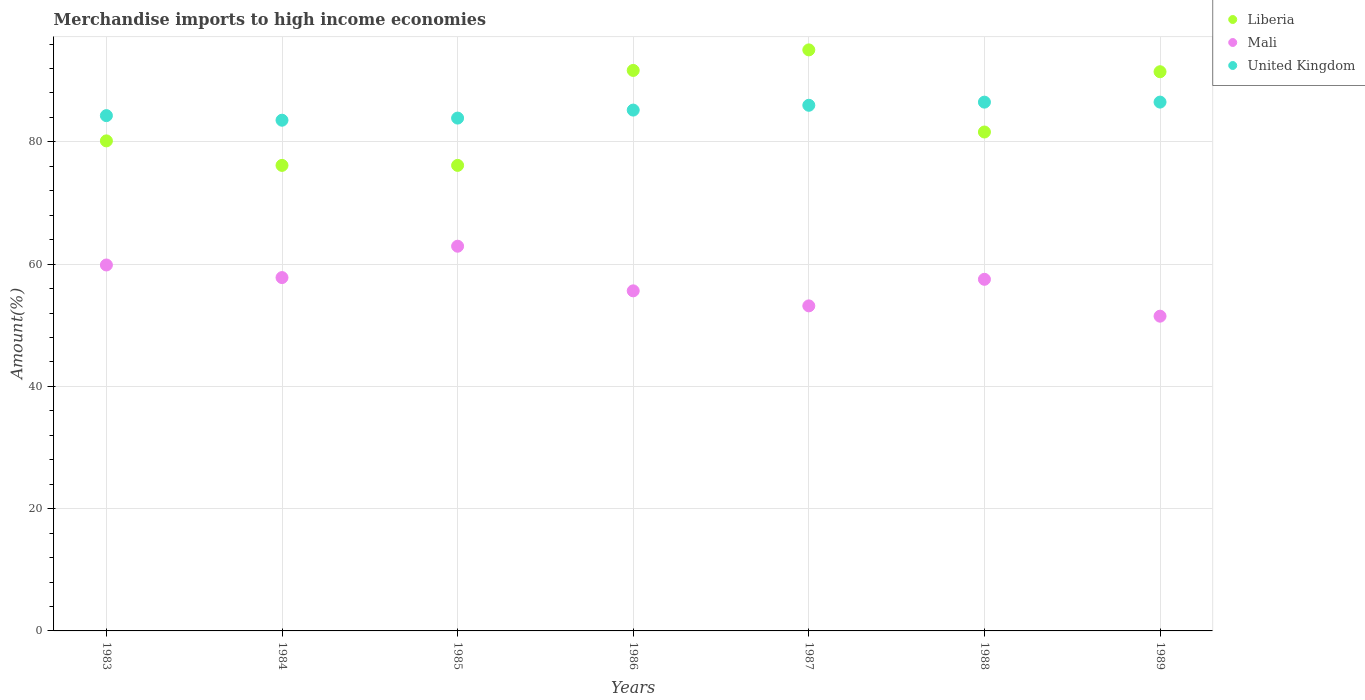How many different coloured dotlines are there?
Your answer should be compact. 3. Is the number of dotlines equal to the number of legend labels?
Give a very brief answer. Yes. What is the percentage of amount earned from merchandise imports in Mali in 1987?
Your response must be concise. 53.17. Across all years, what is the maximum percentage of amount earned from merchandise imports in Liberia?
Provide a succinct answer. 95.04. Across all years, what is the minimum percentage of amount earned from merchandise imports in United Kingdom?
Offer a terse response. 83.54. What is the total percentage of amount earned from merchandise imports in United Kingdom in the graph?
Offer a terse response. 595.89. What is the difference between the percentage of amount earned from merchandise imports in United Kingdom in 1987 and that in 1989?
Your answer should be compact. -0.52. What is the difference between the percentage of amount earned from merchandise imports in Liberia in 1983 and the percentage of amount earned from merchandise imports in United Kingdom in 1989?
Your answer should be very brief. -6.34. What is the average percentage of amount earned from merchandise imports in Mali per year?
Offer a very short reply. 56.91. In the year 1988, what is the difference between the percentage of amount earned from merchandise imports in Mali and percentage of amount earned from merchandise imports in United Kingdom?
Give a very brief answer. -28.98. In how many years, is the percentage of amount earned from merchandise imports in Liberia greater than 28 %?
Provide a short and direct response. 7. What is the ratio of the percentage of amount earned from merchandise imports in Liberia in 1984 to that in 1988?
Your answer should be compact. 0.93. Is the difference between the percentage of amount earned from merchandise imports in Mali in 1983 and 1987 greater than the difference between the percentage of amount earned from merchandise imports in United Kingdom in 1983 and 1987?
Ensure brevity in your answer.  Yes. What is the difference between the highest and the second highest percentage of amount earned from merchandise imports in Mali?
Your response must be concise. 3.07. What is the difference between the highest and the lowest percentage of amount earned from merchandise imports in Mali?
Offer a very short reply. 11.44. Is it the case that in every year, the sum of the percentage of amount earned from merchandise imports in Mali and percentage of amount earned from merchandise imports in United Kingdom  is greater than the percentage of amount earned from merchandise imports in Liberia?
Provide a short and direct response. Yes. Does the percentage of amount earned from merchandise imports in Mali monotonically increase over the years?
Offer a very short reply. No. Is the percentage of amount earned from merchandise imports in United Kingdom strictly greater than the percentage of amount earned from merchandise imports in Mali over the years?
Your answer should be very brief. Yes. How many years are there in the graph?
Ensure brevity in your answer.  7. What is the difference between two consecutive major ticks on the Y-axis?
Your answer should be very brief. 20. Does the graph contain any zero values?
Provide a short and direct response. No. Where does the legend appear in the graph?
Give a very brief answer. Top right. How many legend labels are there?
Provide a succinct answer. 3. How are the legend labels stacked?
Your answer should be very brief. Vertical. What is the title of the graph?
Your answer should be very brief. Merchandise imports to high income economies. Does "Uzbekistan" appear as one of the legend labels in the graph?
Give a very brief answer. No. What is the label or title of the Y-axis?
Your answer should be very brief. Amount(%). What is the Amount(%) in Liberia in 1983?
Offer a very short reply. 80.16. What is the Amount(%) in Mali in 1983?
Provide a succinct answer. 59.86. What is the Amount(%) of United Kingdom in 1983?
Give a very brief answer. 84.29. What is the Amount(%) in Liberia in 1984?
Your response must be concise. 76.15. What is the Amount(%) in Mali in 1984?
Ensure brevity in your answer.  57.8. What is the Amount(%) in United Kingdom in 1984?
Your response must be concise. 83.54. What is the Amount(%) of Liberia in 1985?
Your answer should be compact. 76.15. What is the Amount(%) of Mali in 1985?
Offer a very short reply. 62.93. What is the Amount(%) in United Kingdom in 1985?
Offer a terse response. 83.89. What is the Amount(%) of Liberia in 1986?
Your answer should be very brief. 91.68. What is the Amount(%) in Mali in 1986?
Provide a short and direct response. 55.63. What is the Amount(%) in United Kingdom in 1986?
Make the answer very short. 85.19. What is the Amount(%) of Liberia in 1987?
Your response must be concise. 95.04. What is the Amount(%) of Mali in 1987?
Give a very brief answer. 53.17. What is the Amount(%) in United Kingdom in 1987?
Provide a succinct answer. 85.98. What is the Amount(%) of Liberia in 1988?
Offer a very short reply. 81.61. What is the Amount(%) of Mali in 1988?
Provide a succinct answer. 57.51. What is the Amount(%) in United Kingdom in 1988?
Offer a very short reply. 86.49. What is the Amount(%) of Liberia in 1989?
Your answer should be compact. 91.47. What is the Amount(%) of Mali in 1989?
Your response must be concise. 51.48. What is the Amount(%) of United Kingdom in 1989?
Offer a terse response. 86.5. Across all years, what is the maximum Amount(%) in Liberia?
Your answer should be very brief. 95.04. Across all years, what is the maximum Amount(%) in Mali?
Offer a very short reply. 62.93. Across all years, what is the maximum Amount(%) in United Kingdom?
Offer a terse response. 86.5. Across all years, what is the minimum Amount(%) of Liberia?
Make the answer very short. 76.15. Across all years, what is the minimum Amount(%) of Mali?
Provide a short and direct response. 51.48. Across all years, what is the minimum Amount(%) in United Kingdom?
Make the answer very short. 83.54. What is the total Amount(%) of Liberia in the graph?
Your response must be concise. 592.26. What is the total Amount(%) of Mali in the graph?
Offer a very short reply. 398.38. What is the total Amount(%) in United Kingdom in the graph?
Keep it short and to the point. 595.89. What is the difference between the Amount(%) of Liberia in 1983 and that in 1984?
Make the answer very short. 4.01. What is the difference between the Amount(%) in Mali in 1983 and that in 1984?
Your answer should be compact. 2.06. What is the difference between the Amount(%) in United Kingdom in 1983 and that in 1984?
Make the answer very short. 0.75. What is the difference between the Amount(%) in Liberia in 1983 and that in 1985?
Keep it short and to the point. 4.01. What is the difference between the Amount(%) in Mali in 1983 and that in 1985?
Give a very brief answer. -3.07. What is the difference between the Amount(%) in United Kingdom in 1983 and that in 1985?
Give a very brief answer. 0.4. What is the difference between the Amount(%) of Liberia in 1983 and that in 1986?
Offer a very short reply. -11.52. What is the difference between the Amount(%) of Mali in 1983 and that in 1986?
Ensure brevity in your answer.  4.23. What is the difference between the Amount(%) of United Kingdom in 1983 and that in 1986?
Keep it short and to the point. -0.91. What is the difference between the Amount(%) in Liberia in 1983 and that in 1987?
Ensure brevity in your answer.  -14.88. What is the difference between the Amount(%) of Mali in 1983 and that in 1987?
Make the answer very short. 6.69. What is the difference between the Amount(%) in United Kingdom in 1983 and that in 1987?
Provide a succinct answer. -1.69. What is the difference between the Amount(%) of Liberia in 1983 and that in 1988?
Offer a very short reply. -1.45. What is the difference between the Amount(%) in Mali in 1983 and that in 1988?
Give a very brief answer. 2.34. What is the difference between the Amount(%) of United Kingdom in 1983 and that in 1988?
Your answer should be very brief. -2.21. What is the difference between the Amount(%) in Liberia in 1983 and that in 1989?
Your answer should be very brief. -11.31. What is the difference between the Amount(%) in Mali in 1983 and that in 1989?
Provide a short and direct response. 8.37. What is the difference between the Amount(%) of United Kingdom in 1983 and that in 1989?
Provide a succinct answer. -2.21. What is the difference between the Amount(%) in Mali in 1984 and that in 1985?
Offer a very short reply. -5.13. What is the difference between the Amount(%) in United Kingdom in 1984 and that in 1985?
Provide a succinct answer. -0.35. What is the difference between the Amount(%) in Liberia in 1984 and that in 1986?
Offer a very short reply. -15.53. What is the difference between the Amount(%) in Mali in 1984 and that in 1986?
Ensure brevity in your answer.  2.17. What is the difference between the Amount(%) in United Kingdom in 1984 and that in 1986?
Your response must be concise. -1.66. What is the difference between the Amount(%) in Liberia in 1984 and that in 1987?
Keep it short and to the point. -18.89. What is the difference between the Amount(%) of Mali in 1984 and that in 1987?
Offer a terse response. 4.63. What is the difference between the Amount(%) of United Kingdom in 1984 and that in 1987?
Offer a terse response. -2.44. What is the difference between the Amount(%) of Liberia in 1984 and that in 1988?
Make the answer very short. -5.46. What is the difference between the Amount(%) in Mali in 1984 and that in 1988?
Your answer should be compact. 0.28. What is the difference between the Amount(%) of United Kingdom in 1984 and that in 1988?
Make the answer very short. -2.96. What is the difference between the Amount(%) in Liberia in 1984 and that in 1989?
Provide a succinct answer. -15.32. What is the difference between the Amount(%) in Mali in 1984 and that in 1989?
Give a very brief answer. 6.31. What is the difference between the Amount(%) of United Kingdom in 1984 and that in 1989?
Offer a terse response. -2.96. What is the difference between the Amount(%) in Liberia in 1985 and that in 1986?
Your answer should be very brief. -15.53. What is the difference between the Amount(%) in Mali in 1985 and that in 1986?
Give a very brief answer. 7.3. What is the difference between the Amount(%) in United Kingdom in 1985 and that in 1986?
Ensure brevity in your answer.  -1.31. What is the difference between the Amount(%) in Liberia in 1985 and that in 1987?
Make the answer very short. -18.89. What is the difference between the Amount(%) of Mali in 1985 and that in 1987?
Offer a terse response. 9.76. What is the difference between the Amount(%) in United Kingdom in 1985 and that in 1987?
Keep it short and to the point. -2.1. What is the difference between the Amount(%) in Liberia in 1985 and that in 1988?
Your response must be concise. -5.46. What is the difference between the Amount(%) in Mali in 1985 and that in 1988?
Keep it short and to the point. 5.41. What is the difference between the Amount(%) in United Kingdom in 1985 and that in 1988?
Make the answer very short. -2.61. What is the difference between the Amount(%) of Liberia in 1985 and that in 1989?
Provide a succinct answer. -15.32. What is the difference between the Amount(%) in Mali in 1985 and that in 1989?
Provide a short and direct response. 11.44. What is the difference between the Amount(%) of United Kingdom in 1985 and that in 1989?
Make the answer very short. -2.62. What is the difference between the Amount(%) in Liberia in 1986 and that in 1987?
Make the answer very short. -3.36. What is the difference between the Amount(%) of Mali in 1986 and that in 1987?
Provide a short and direct response. 2.46. What is the difference between the Amount(%) of United Kingdom in 1986 and that in 1987?
Your response must be concise. -0.79. What is the difference between the Amount(%) in Liberia in 1986 and that in 1988?
Your answer should be very brief. 10.07. What is the difference between the Amount(%) of Mali in 1986 and that in 1988?
Provide a short and direct response. -1.89. What is the difference between the Amount(%) in Liberia in 1986 and that in 1989?
Keep it short and to the point. 0.21. What is the difference between the Amount(%) in Mali in 1986 and that in 1989?
Provide a succinct answer. 4.14. What is the difference between the Amount(%) in United Kingdom in 1986 and that in 1989?
Your response must be concise. -1.31. What is the difference between the Amount(%) in Liberia in 1987 and that in 1988?
Offer a terse response. 13.43. What is the difference between the Amount(%) of Mali in 1987 and that in 1988?
Ensure brevity in your answer.  -4.35. What is the difference between the Amount(%) in United Kingdom in 1987 and that in 1988?
Keep it short and to the point. -0.51. What is the difference between the Amount(%) in Liberia in 1987 and that in 1989?
Offer a very short reply. 3.57. What is the difference between the Amount(%) of Mali in 1987 and that in 1989?
Make the answer very short. 1.69. What is the difference between the Amount(%) of United Kingdom in 1987 and that in 1989?
Your answer should be compact. -0.52. What is the difference between the Amount(%) of Liberia in 1988 and that in 1989?
Provide a short and direct response. -9.86. What is the difference between the Amount(%) of Mali in 1988 and that in 1989?
Offer a very short reply. 6.03. What is the difference between the Amount(%) in United Kingdom in 1988 and that in 1989?
Offer a very short reply. -0.01. What is the difference between the Amount(%) in Liberia in 1983 and the Amount(%) in Mali in 1984?
Keep it short and to the point. 22.36. What is the difference between the Amount(%) of Liberia in 1983 and the Amount(%) of United Kingdom in 1984?
Offer a terse response. -3.38. What is the difference between the Amount(%) in Mali in 1983 and the Amount(%) in United Kingdom in 1984?
Provide a succinct answer. -23.68. What is the difference between the Amount(%) in Liberia in 1983 and the Amount(%) in Mali in 1985?
Offer a terse response. 17.23. What is the difference between the Amount(%) in Liberia in 1983 and the Amount(%) in United Kingdom in 1985?
Your answer should be very brief. -3.73. What is the difference between the Amount(%) in Mali in 1983 and the Amount(%) in United Kingdom in 1985?
Ensure brevity in your answer.  -24.03. What is the difference between the Amount(%) in Liberia in 1983 and the Amount(%) in Mali in 1986?
Give a very brief answer. 24.53. What is the difference between the Amount(%) in Liberia in 1983 and the Amount(%) in United Kingdom in 1986?
Your answer should be compact. -5.04. What is the difference between the Amount(%) in Mali in 1983 and the Amount(%) in United Kingdom in 1986?
Your answer should be compact. -25.34. What is the difference between the Amount(%) of Liberia in 1983 and the Amount(%) of Mali in 1987?
Your answer should be very brief. 26.99. What is the difference between the Amount(%) of Liberia in 1983 and the Amount(%) of United Kingdom in 1987?
Give a very brief answer. -5.82. What is the difference between the Amount(%) of Mali in 1983 and the Amount(%) of United Kingdom in 1987?
Give a very brief answer. -26.12. What is the difference between the Amount(%) in Liberia in 1983 and the Amount(%) in Mali in 1988?
Provide a short and direct response. 22.64. What is the difference between the Amount(%) in Liberia in 1983 and the Amount(%) in United Kingdom in 1988?
Your answer should be very brief. -6.34. What is the difference between the Amount(%) of Mali in 1983 and the Amount(%) of United Kingdom in 1988?
Offer a very short reply. -26.64. What is the difference between the Amount(%) of Liberia in 1983 and the Amount(%) of Mali in 1989?
Offer a very short reply. 28.67. What is the difference between the Amount(%) in Liberia in 1983 and the Amount(%) in United Kingdom in 1989?
Your answer should be compact. -6.34. What is the difference between the Amount(%) of Mali in 1983 and the Amount(%) of United Kingdom in 1989?
Provide a succinct answer. -26.64. What is the difference between the Amount(%) in Liberia in 1984 and the Amount(%) in Mali in 1985?
Make the answer very short. 13.22. What is the difference between the Amount(%) in Liberia in 1984 and the Amount(%) in United Kingdom in 1985?
Offer a terse response. -7.74. What is the difference between the Amount(%) in Mali in 1984 and the Amount(%) in United Kingdom in 1985?
Ensure brevity in your answer.  -26.09. What is the difference between the Amount(%) of Liberia in 1984 and the Amount(%) of Mali in 1986?
Provide a short and direct response. 20.52. What is the difference between the Amount(%) of Liberia in 1984 and the Amount(%) of United Kingdom in 1986?
Give a very brief answer. -9.05. What is the difference between the Amount(%) of Mali in 1984 and the Amount(%) of United Kingdom in 1986?
Give a very brief answer. -27.4. What is the difference between the Amount(%) of Liberia in 1984 and the Amount(%) of Mali in 1987?
Offer a terse response. 22.98. What is the difference between the Amount(%) of Liberia in 1984 and the Amount(%) of United Kingdom in 1987?
Offer a terse response. -9.83. What is the difference between the Amount(%) in Mali in 1984 and the Amount(%) in United Kingdom in 1987?
Your response must be concise. -28.18. What is the difference between the Amount(%) of Liberia in 1984 and the Amount(%) of Mali in 1988?
Give a very brief answer. 18.63. What is the difference between the Amount(%) in Liberia in 1984 and the Amount(%) in United Kingdom in 1988?
Provide a succinct answer. -10.35. What is the difference between the Amount(%) of Mali in 1984 and the Amount(%) of United Kingdom in 1988?
Give a very brief answer. -28.7. What is the difference between the Amount(%) in Liberia in 1984 and the Amount(%) in Mali in 1989?
Make the answer very short. 24.67. What is the difference between the Amount(%) in Liberia in 1984 and the Amount(%) in United Kingdom in 1989?
Keep it short and to the point. -10.35. What is the difference between the Amount(%) of Mali in 1984 and the Amount(%) of United Kingdom in 1989?
Give a very brief answer. -28.7. What is the difference between the Amount(%) of Liberia in 1985 and the Amount(%) of Mali in 1986?
Offer a terse response. 20.52. What is the difference between the Amount(%) in Liberia in 1985 and the Amount(%) in United Kingdom in 1986?
Make the answer very short. -9.05. What is the difference between the Amount(%) in Mali in 1985 and the Amount(%) in United Kingdom in 1986?
Give a very brief answer. -22.27. What is the difference between the Amount(%) in Liberia in 1985 and the Amount(%) in Mali in 1987?
Give a very brief answer. 22.98. What is the difference between the Amount(%) in Liberia in 1985 and the Amount(%) in United Kingdom in 1987?
Your answer should be very brief. -9.83. What is the difference between the Amount(%) of Mali in 1985 and the Amount(%) of United Kingdom in 1987?
Make the answer very short. -23.05. What is the difference between the Amount(%) of Liberia in 1985 and the Amount(%) of Mali in 1988?
Your answer should be compact. 18.63. What is the difference between the Amount(%) of Liberia in 1985 and the Amount(%) of United Kingdom in 1988?
Your answer should be very brief. -10.35. What is the difference between the Amount(%) in Mali in 1985 and the Amount(%) in United Kingdom in 1988?
Your response must be concise. -23.57. What is the difference between the Amount(%) in Liberia in 1985 and the Amount(%) in Mali in 1989?
Offer a very short reply. 24.67. What is the difference between the Amount(%) in Liberia in 1985 and the Amount(%) in United Kingdom in 1989?
Provide a short and direct response. -10.35. What is the difference between the Amount(%) of Mali in 1985 and the Amount(%) of United Kingdom in 1989?
Provide a succinct answer. -23.57. What is the difference between the Amount(%) in Liberia in 1986 and the Amount(%) in Mali in 1987?
Give a very brief answer. 38.51. What is the difference between the Amount(%) of Liberia in 1986 and the Amount(%) of United Kingdom in 1987?
Make the answer very short. 5.7. What is the difference between the Amount(%) of Mali in 1986 and the Amount(%) of United Kingdom in 1987?
Ensure brevity in your answer.  -30.35. What is the difference between the Amount(%) of Liberia in 1986 and the Amount(%) of Mali in 1988?
Keep it short and to the point. 34.17. What is the difference between the Amount(%) of Liberia in 1986 and the Amount(%) of United Kingdom in 1988?
Provide a succinct answer. 5.19. What is the difference between the Amount(%) in Mali in 1986 and the Amount(%) in United Kingdom in 1988?
Give a very brief answer. -30.87. What is the difference between the Amount(%) of Liberia in 1986 and the Amount(%) of Mali in 1989?
Your answer should be very brief. 40.2. What is the difference between the Amount(%) of Liberia in 1986 and the Amount(%) of United Kingdom in 1989?
Ensure brevity in your answer.  5.18. What is the difference between the Amount(%) in Mali in 1986 and the Amount(%) in United Kingdom in 1989?
Keep it short and to the point. -30.87. What is the difference between the Amount(%) of Liberia in 1987 and the Amount(%) of Mali in 1988?
Ensure brevity in your answer.  37.53. What is the difference between the Amount(%) in Liberia in 1987 and the Amount(%) in United Kingdom in 1988?
Ensure brevity in your answer.  8.55. What is the difference between the Amount(%) of Mali in 1987 and the Amount(%) of United Kingdom in 1988?
Offer a very short reply. -33.33. What is the difference between the Amount(%) of Liberia in 1987 and the Amount(%) of Mali in 1989?
Offer a very short reply. 43.56. What is the difference between the Amount(%) in Liberia in 1987 and the Amount(%) in United Kingdom in 1989?
Your answer should be very brief. 8.54. What is the difference between the Amount(%) of Mali in 1987 and the Amount(%) of United Kingdom in 1989?
Your response must be concise. -33.33. What is the difference between the Amount(%) of Liberia in 1988 and the Amount(%) of Mali in 1989?
Make the answer very short. 30.13. What is the difference between the Amount(%) of Liberia in 1988 and the Amount(%) of United Kingdom in 1989?
Ensure brevity in your answer.  -4.89. What is the difference between the Amount(%) of Mali in 1988 and the Amount(%) of United Kingdom in 1989?
Give a very brief answer. -28.99. What is the average Amount(%) of Liberia per year?
Your answer should be compact. 84.61. What is the average Amount(%) in Mali per year?
Ensure brevity in your answer.  56.91. What is the average Amount(%) of United Kingdom per year?
Make the answer very short. 85.13. In the year 1983, what is the difference between the Amount(%) in Liberia and Amount(%) in Mali?
Provide a succinct answer. 20.3. In the year 1983, what is the difference between the Amount(%) in Liberia and Amount(%) in United Kingdom?
Ensure brevity in your answer.  -4.13. In the year 1983, what is the difference between the Amount(%) of Mali and Amount(%) of United Kingdom?
Keep it short and to the point. -24.43. In the year 1984, what is the difference between the Amount(%) in Liberia and Amount(%) in Mali?
Your answer should be compact. 18.35. In the year 1984, what is the difference between the Amount(%) of Liberia and Amount(%) of United Kingdom?
Your response must be concise. -7.39. In the year 1984, what is the difference between the Amount(%) in Mali and Amount(%) in United Kingdom?
Keep it short and to the point. -25.74. In the year 1985, what is the difference between the Amount(%) in Liberia and Amount(%) in Mali?
Keep it short and to the point. 13.22. In the year 1985, what is the difference between the Amount(%) in Liberia and Amount(%) in United Kingdom?
Keep it short and to the point. -7.74. In the year 1985, what is the difference between the Amount(%) of Mali and Amount(%) of United Kingdom?
Keep it short and to the point. -20.96. In the year 1986, what is the difference between the Amount(%) of Liberia and Amount(%) of Mali?
Your response must be concise. 36.06. In the year 1986, what is the difference between the Amount(%) in Liberia and Amount(%) in United Kingdom?
Make the answer very short. 6.49. In the year 1986, what is the difference between the Amount(%) in Mali and Amount(%) in United Kingdom?
Offer a terse response. -29.57. In the year 1987, what is the difference between the Amount(%) in Liberia and Amount(%) in Mali?
Your response must be concise. 41.87. In the year 1987, what is the difference between the Amount(%) in Liberia and Amount(%) in United Kingdom?
Ensure brevity in your answer.  9.06. In the year 1987, what is the difference between the Amount(%) of Mali and Amount(%) of United Kingdom?
Provide a succinct answer. -32.81. In the year 1988, what is the difference between the Amount(%) in Liberia and Amount(%) in Mali?
Provide a short and direct response. 24.1. In the year 1988, what is the difference between the Amount(%) in Liberia and Amount(%) in United Kingdom?
Your response must be concise. -4.88. In the year 1988, what is the difference between the Amount(%) in Mali and Amount(%) in United Kingdom?
Ensure brevity in your answer.  -28.98. In the year 1989, what is the difference between the Amount(%) in Liberia and Amount(%) in Mali?
Ensure brevity in your answer.  39.98. In the year 1989, what is the difference between the Amount(%) in Liberia and Amount(%) in United Kingdom?
Offer a terse response. 4.97. In the year 1989, what is the difference between the Amount(%) of Mali and Amount(%) of United Kingdom?
Provide a succinct answer. -35.02. What is the ratio of the Amount(%) in Liberia in 1983 to that in 1984?
Keep it short and to the point. 1.05. What is the ratio of the Amount(%) of Mali in 1983 to that in 1984?
Offer a very short reply. 1.04. What is the ratio of the Amount(%) of United Kingdom in 1983 to that in 1984?
Offer a very short reply. 1.01. What is the ratio of the Amount(%) in Liberia in 1983 to that in 1985?
Provide a succinct answer. 1.05. What is the ratio of the Amount(%) in Mali in 1983 to that in 1985?
Ensure brevity in your answer.  0.95. What is the ratio of the Amount(%) of United Kingdom in 1983 to that in 1985?
Your answer should be very brief. 1. What is the ratio of the Amount(%) of Liberia in 1983 to that in 1986?
Provide a short and direct response. 0.87. What is the ratio of the Amount(%) in Mali in 1983 to that in 1986?
Keep it short and to the point. 1.08. What is the ratio of the Amount(%) of Liberia in 1983 to that in 1987?
Give a very brief answer. 0.84. What is the ratio of the Amount(%) in Mali in 1983 to that in 1987?
Your answer should be very brief. 1.13. What is the ratio of the Amount(%) of United Kingdom in 1983 to that in 1987?
Offer a very short reply. 0.98. What is the ratio of the Amount(%) of Liberia in 1983 to that in 1988?
Provide a succinct answer. 0.98. What is the ratio of the Amount(%) in Mali in 1983 to that in 1988?
Make the answer very short. 1.04. What is the ratio of the Amount(%) in United Kingdom in 1983 to that in 1988?
Keep it short and to the point. 0.97. What is the ratio of the Amount(%) of Liberia in 1983 to that in 1989?
Offer a terse response. 0.88. What is the ratio of the Amount(%) of Mali in 1983 to that in 1989?
Offer a very short reply. 1.16. What is the ratio of the Amount(%) of United Kingdom in 1983 to that in 1989?
Provide a succinct answer. 0.97. What is the ratio of the Amount(%) of Mali in 1984 to that in 1985?
Offer a terse response. 0.92. What is the ratio of the Amount(%) in United Kingdom in 1984 to that in 1985?
Your answer should be compact. 1. What is the ratio of the Amount(%) in Liberia in 1984 to that in 1986?
Your answer should be very brief. 0.83. What is the ratio of the Amount(%) in Mali in 1984 to that in 1986?
Give a very brief answer. 1.04. What is the ratio of the Amount(%) of United Kingdom in 1984 to that in 1986?
Provide a succinct answer. 0.98. What is the ratio of the Amount(%) in Liberia in 1984 to that in 1987?
Make the answer very short. 0.8. What is the ratio of the Amount(%) of Mali in 1984 to that in 1987?
Your answer should be compact. 1.09. What is the ratio of the Amount(%) in United Kingdom in 1984 to that in 1987?
Your answer should be very brief. 0.97. What is the ratio of the Amount(%) in Liberia in 1984 to that in 1988?
Make the answer very short. 0.93. What is the ratio of the Amount(%) in United Kingdom in 1984 to that in 1988?
Your response must be concise. 0.97. What is the ratio of the Amount(%) of Liberia in 1984 to that in 1989?
Provide a succinct answer. 0.83. What is the ratio of the Amount(%) in Mali in 1984 to that in 1989?
Your response must be concise. 1.12. What is the ratio of the Amount(%) in United Kingdom in 1984 to that in 1989?
Keep it short and to the point. 0.97. What is the ratio of the Amount(%) of Liberia in 1985 to that in 1986?
Offer a terse response. 0.83. What is the ratio of the Amount(%) of Mali in 1985 to that in 1986?
Keep it short and to the point. 1.13. What is the ratio of the Amount(%) of United Kingdom in 1985 to that in 1986?
Give a very brief answer. 0.98. What is the ratio of the Amount(%) in Liberia in 1985 to that in 1987?
Make the answer very short. 0.8. What is the ratio of the Amount(%) in Mali in 1985 to that in 1987?
Give a very brief answer. 1.18. What is the ratio of the Amount(%) in United Kingdom in 1985 to that in 1987?
Provide a short and direct response. 0.98. What is the ratio of the Amount(%) in Liberia in 1985 to that in 1988?
Provide a succinct answer. 0.93. What is the ratio of the Amount(%) in Mali in 1985 to that in 1988?
Offer a terse response. 1.09. What is the ratio of the Amount(%) of United Kingdom in 1985 to that in 1988?
Give a very brief answer. 0.97. What is the ratio of the Amount(%) in Liberia in 1985 to that in 1989?
Your response must be concise. 0.83. What is the ratio of the Amount(%) in Mali in 1985 to that in 1989?
Provide a succinct answer. 1.22. What is the ratio of the Amount(%) of United Kingdom in 1985 to that in 1989?
Provide a succinct answer. 0.97. What is the ratio of the Amount(%) in Liberia in 1986 to that in 1987?
Provide a succinct answer. 0.96. What is the ratio of the Amount(%) of Mali in 1986 to that in 1987?
Your answer should be compact. 1.05. What is the ratio of the Amount(%) of United Kingdom in 1986 to that in 1987?
Your response must be concise. 0.99. What is the ratio of the Amount(%) in Liberia in 1986 to that in 1988?
Make the answer very short. 1.12. What is the ratio of the Amount(%) of Mali in 1986 to that in 1988?
Your answer should be very brief. 0.97. What is the ratio of the Amount(%) of United Kingdom in 1986 to that in 1988?
Offer a terse response. 0.98. What is the ratio of the Amount(%) in Mali in 1986 to that in 1989?
Your answer should be compact. 1.08. What is the ratio of the Amount(%) in United Kingdom in 1986 to that in 1989?
Keep it short and to the point. 0.98. What is the ratio of the Amount(%) of Liberia in 1987 to that in 1988?
Provide a succinct answer. 1.16. What is the ratio of the Amount(%) of Mali in 1987 to that in 1988?
Your response must be concise. 0.92. What is the ratio of the Amount(%) of United Kingdom in 1987 to that in 1988?
Ensure brevity in your answer.  0.99. What is the ratio of the Amount(%) of Liberia in 1987 to that in 1989?
Keep it short and to the point. 1.04. What is the ratio of the Amount(%) of Mali in 1987 to that in 1989?
Your response must be concise. 1.03. What is the ratio of the Amount(%) in United Kingdom in 1987 to that in 1989?
Keep it short and to the point. 0.99. What is the ratio of the Amount(%) in Liberia in 1988 to that in 1989?
Keep it short and to the point. 0.89. What is the ratio of the Amount(%) in Mali in 1988 to that in 1989?
Give a very brief answer. 1.12. What is the ratio of the Amount(%) of United Kingdom in 1988 to that in 1989?
Your response must be concise. 1. What is the difference between the highest and the second highest Amount(%) in Liberia?
Offer a terse response. 3.36. What is the difference between the highest and the second highest Amount(%) in Mali?
Offer a very short reply. 3.07. What is the difference between the highest and the second highest Amount(%) of United Kingdom?
Offer a terse response. 0.01. What is the difference between the highest and the lowest Amount(%) in Liberia?
Offer a very short reply. 18.89. What is the difference between the highest and the lowest Amount(%) in Mali?
Offer a very short reply. 11.44. What is the difference between the highest and the lowest Amount(%) of United Kingdom?
Give a very brief answer. 2.96. 